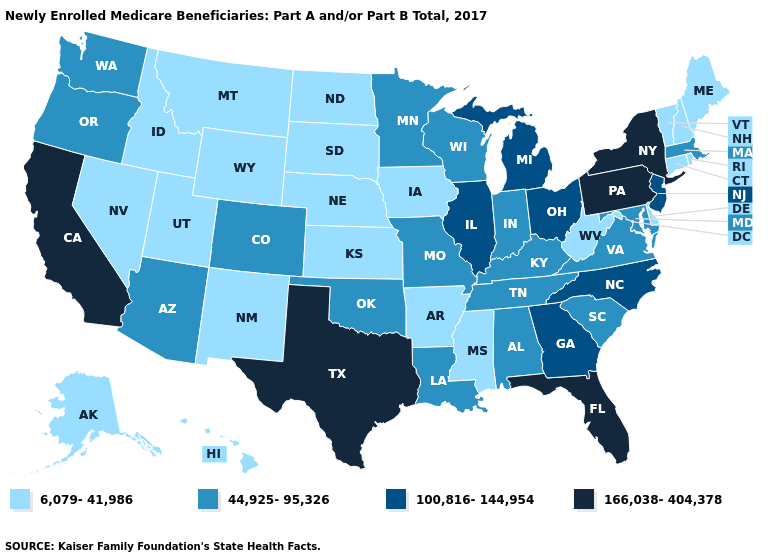Among the states that border Kentucky , does Illinois have the highest value?
Give a very brief answer. Yes. Among the states that border Vermont , which have the lowest value?
Write a very short answer. New Hampshire. What is the value of Maine?
Answer briefly. 6,079-41,986. Does Iowa have the highest value in the USA?
Be succinct. No. What is the value of New Jersey?
Short answer required. 100,816-144,954. What is the highest value in the USA?
Short answer required. 166,038-404,378. What is the value of Oregon?
Write a very short answer. 44,925-95,326. Name the states that have a value in the range 100,816-144,954?
Keep it brief. Georgia, Illinois, Michigan, New Jersey, North Carolina, Ohio. Among the states that border Vermont , which have the highest value?
Short answer required. New York. What is the value of Arkansas?
Quick response, please. 6,079-41,986. What is the value of Arizona?
Give a very brief answer. 44,925-95,326. What is the lowest value in the USA?
Keep it brief. 6,079-41,986. Name the states that have a value in the range 6,079-41,986?
Quick response, please. Alaska, Arkansas, Connecticut, Delaware, Hawaii, Idaho, Iowa, Kansas, Maine, Mississippi, Montana, Nebraska, Nevada, New Hampshire, New Mexico, North Dakota, Rhode Island, South Dakota, Utah, Vermont, West Virginia, Wyoming. Which states have the lowest value in the USA?
Answer briefly. Alaska, Arkansas, Connecticut, Delaware, Hawaii, Idaho, Iowa, Kansas, Maine, Mississippi, Montana, Nebraska, Nevada, New Hampshire, New Mexico, North Dakota, Rhode Island, South Dakota, Utah, Vermont, West Virginia, Wyoming. 